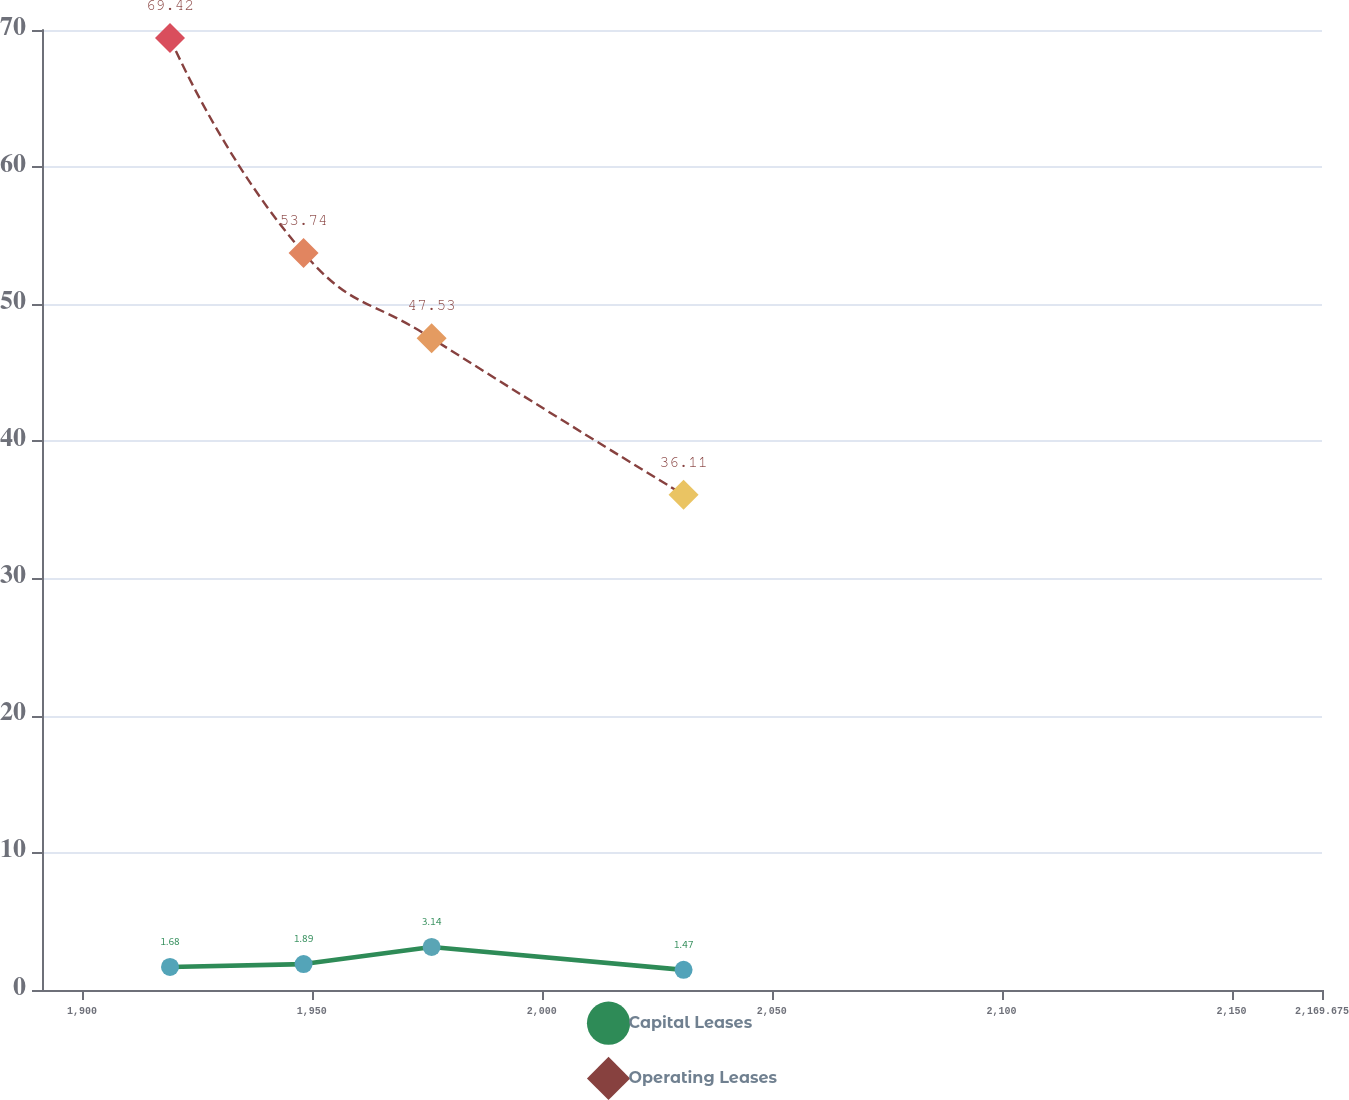<chart> <loc_0><loc_0><loc_500><loc_500><line_chart><ecel><fcel>Capital Leases<fcel>Operating Leases<nl><fcel>1919.16<fcel>1.68<fcel>69.42<nl><fcel>1948.21<fcel>1.89<fcel>53.74<nl><fcel>1976.05<fcel>3.14<fcel>47.53<nl><fcel>2030.84<fcel>1.47<fcel>36.11<nl><fcel>2197.51<fcel>1.03<fcel>25.36<nl></chart> 